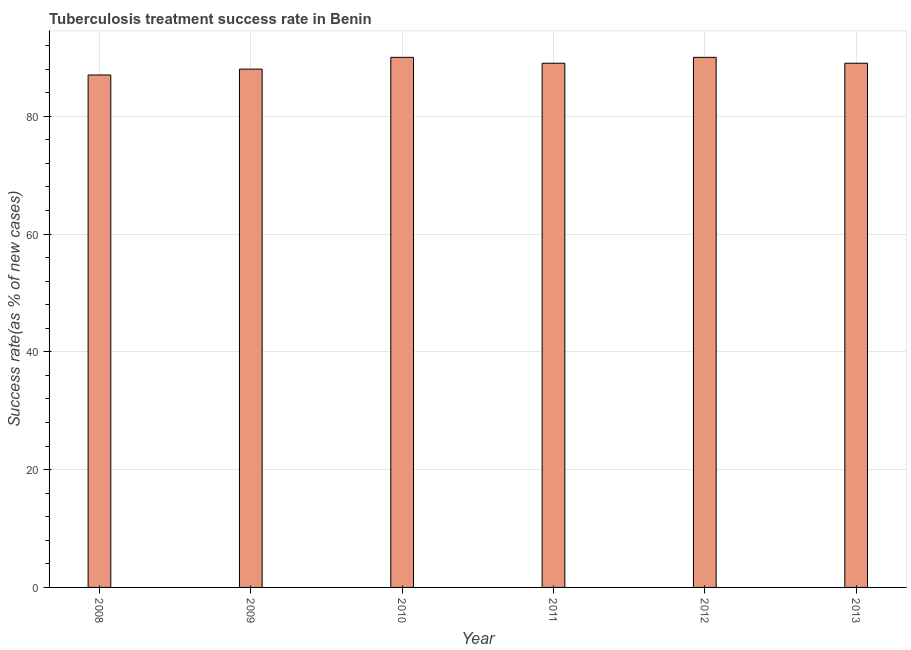Does the graph contain grids?
Make the answer very short. Yes. What is the title of the graph?
Make the answer very short. Tuberculosis treatment success rate in Benin. What is the label or title of the X-axis?
Give a very brief answer. Year. What is the label or title of the Y-axis?
Offer a very short reply. Success rate(as % of new cases). What is the tuberculosis treatment success rate in 2010?
Your answer should be very brief. 90. Across all years, what is the maximum tuberculosis treatment success rate?
Offer a terse response. 90. Across all years, what is the minimum tuberculosis treatment success rate?
Your answer should be compact. 87. In which year was the tuberculosis treatment success rate maximum?
Offer a terse response. 2010. What is the sum of the tuberculosis treatment success rate?
Your answer should be compact. 533. What is the difference between the tuberculosis treatment success rate in 2009 and 2013?
Provide a succinct answer. -1. What is the average tuberculosis treatment success rate per year?
Your answer should be very brief. 88. What is the median tuberculosis treatment success rate?
Give a very brief answer. 89. Is the tuberculosis treatment success rate in 2008 less than that in 2012?
Provide a short and direct response. Yes. Is the sum of the tuberculosis treatment success rate in 2010 and 2011 greater than the maximum tuberculosis treatment success rate across all years?
Offer a terse response. Yes. What is the difference between the highest and the lowest tuberculosis treatment success rate?
Provide a succinct answer. 3. In how many years, is the tuberculosis treatment success rate greater than the average tuberculosis treatment success rate taken over all years?
Ensure brevity in your answer.  4. How many years are there in the graph?
Offer a very short reply. 6. What is the difference between two consecutive major ticks on the Y-axis?
Give a very brief answer. 20. What is the Success rate(as % of new cases) in 2008?
Your answer should be compact. 87. What is the Success rate(as % of new cases) of 2009?
Offer a terse response. 88. What is the Success rate(as % of new cases) in 2010?
Ensure brevity in your answer.  90. What is the Success rate(as % of new cases) in 2011?
Your answer should be compact. 89. What is the Success rate(as % of new cases) of 2013?
Ensure brevity in your answer.  89. What is the difference between the Success rate(as % of new cases) in 2008 and 2010?
Your answer should be very brief. -3. What is the difference between the Success rate(as % of new cases) in 2009 and 2011?
Your response must be concise. -1. What is the difference between the Success rate(as % of new cases) in 2009 and 2012?
Provide a succinct answer. -2. What is the difference between the Success rate(as % of new cases) in 2010 and 2011?
Keep it short and to the point. 1. What is the difference between the Success rate(as % of new cases) in 2010 and 2013?
Offer a terse response. 1. What is the difference between the Success rate(as % of new cases) in 2011 and 2012?
Provide a short and direct response. -1. What is the difference between the Success rate(as % of new cases) in 2011 and 2013?
Offer a very short reply. 0. What is the difference between the Success rate(as % of new cases) in 2012 and 2013?
Keep it short and to the point. 1. What is the ratio of the Success rate(as % of new cases) in 2008 to that in 2009?
Your answer should be compact. 0.99. What is the ratio of the Success rate(as % of new cases) in 2008 to that in 2011?
Your response must be concise. 0.98. What is the ratio of the Success rate(as % of new cases) in 2008 to that in 2013?
Give a very brief answer. 0.98. What is the ratio of the Success rate(as % of new cases) in 2009 to that in 2010?
Make the answer very short. 0.98. What is the ratio of the Success rate(as % of new cases) in 2010 to that in 2011?
Your answer should be very brief. 1.01. What is the ratio of the Success rate(as % of new cases) in 2010 to that in 2012?
Give a very brief answer. 1. What is the ratio of the Success rate(as % of new cases) in 2010 to that in 2013?
Offer a terse response. 1.01. What is the ratio of the Success rate(as % of new cases) in 2012 to that in 2013?
Offer a very short reply. 1.01. 